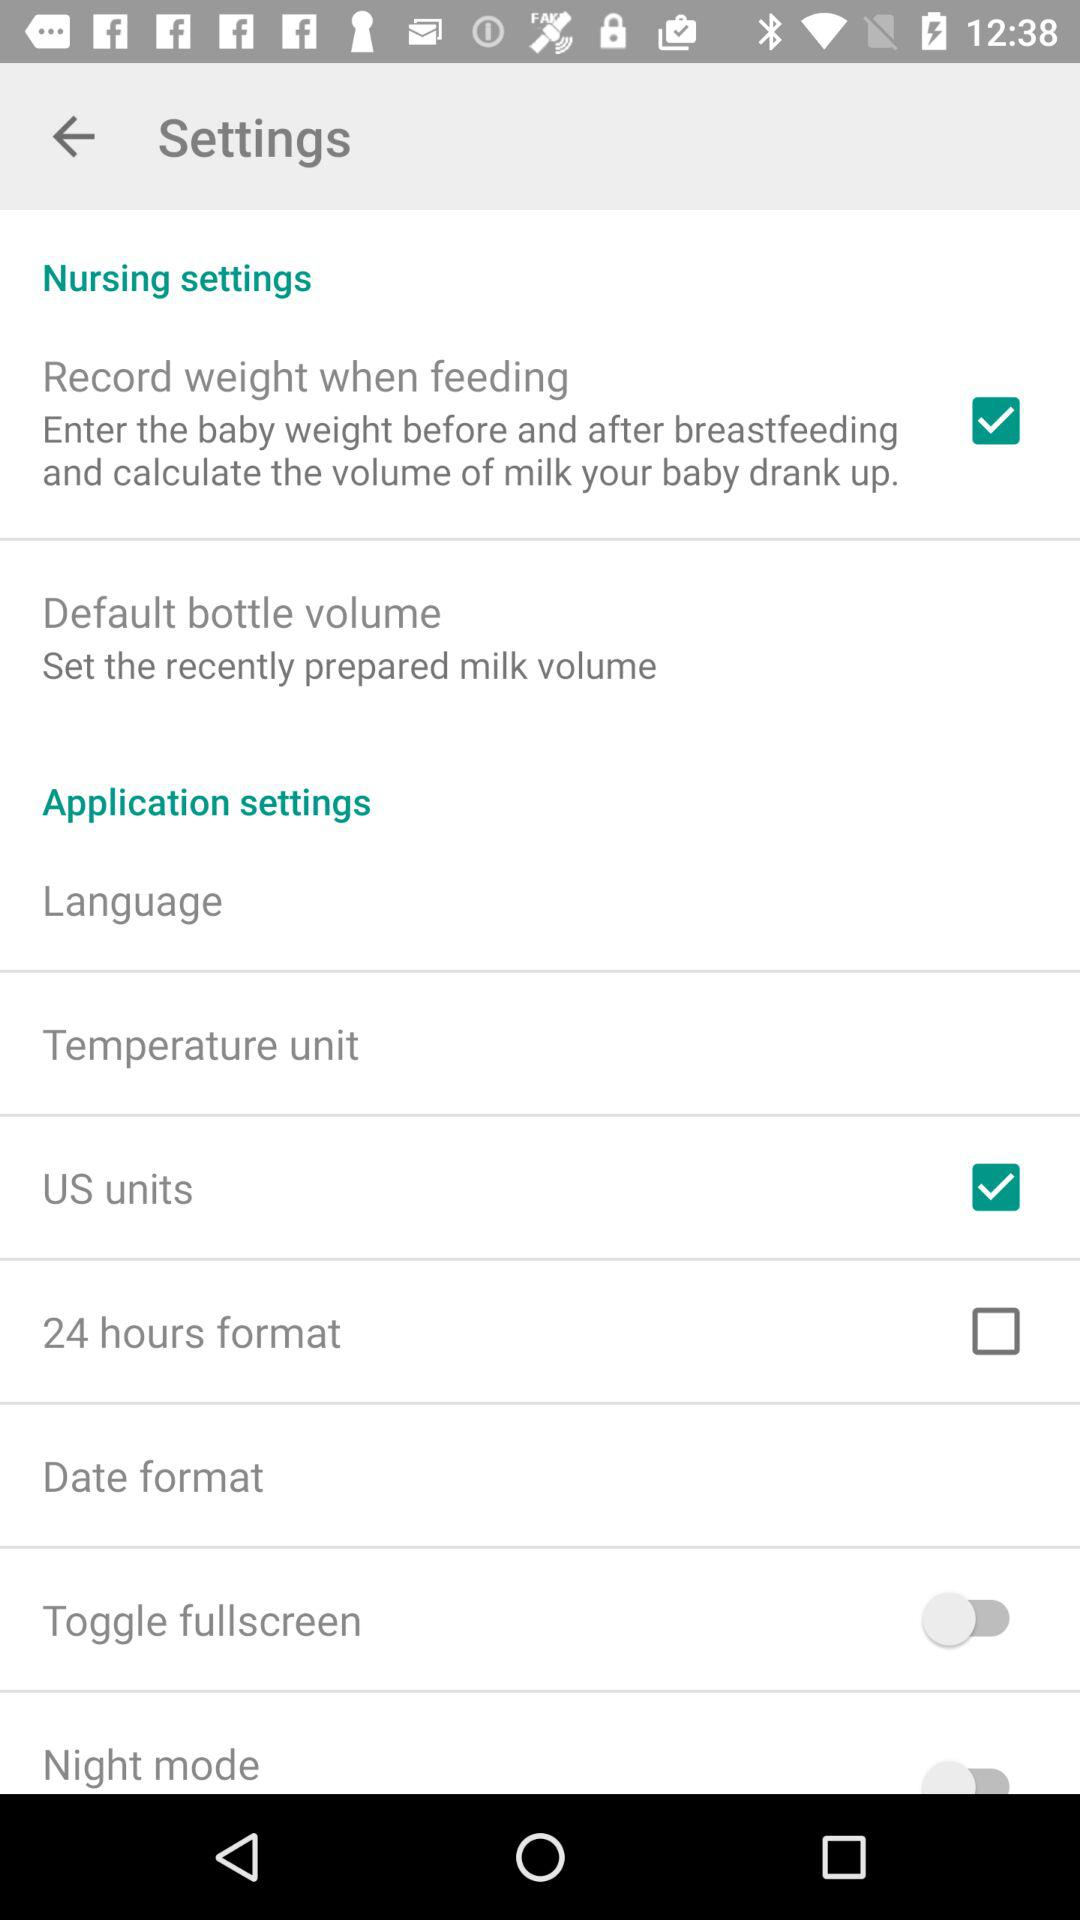What time format is used in "Settings"? The time format is 24 hours. 